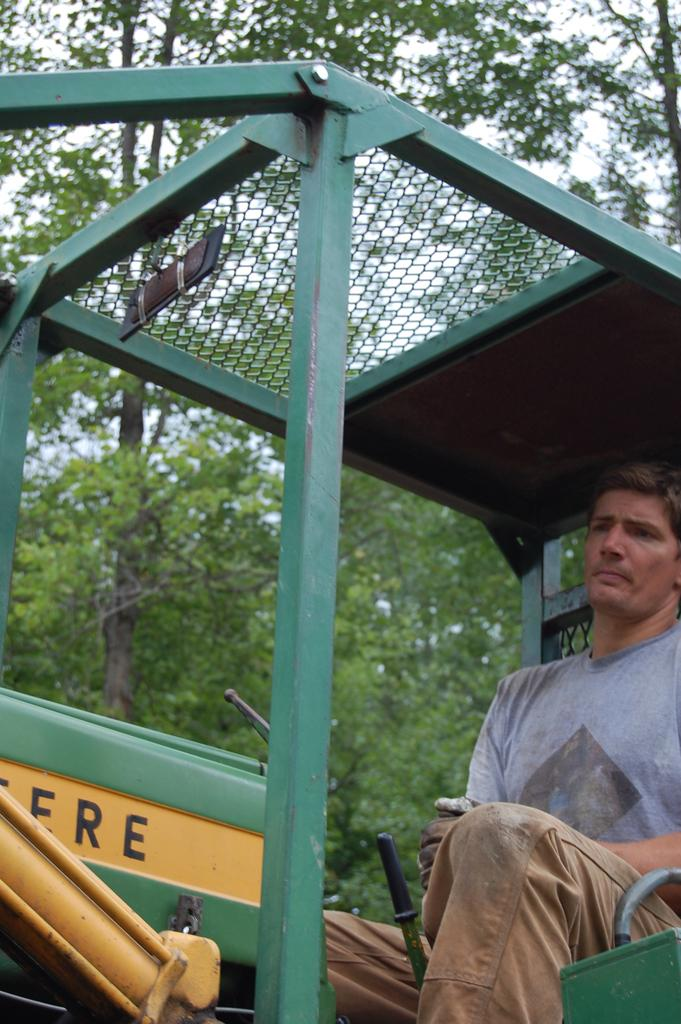What is the person in the image doing? There is a person sitting on a vehicle in the image. What can be seen in the background of the image? There are trees and the sky visible in the background of the image. What type of stick can be seen in the person's hand in the image? There is no stick present in the person's hand or in the image. 